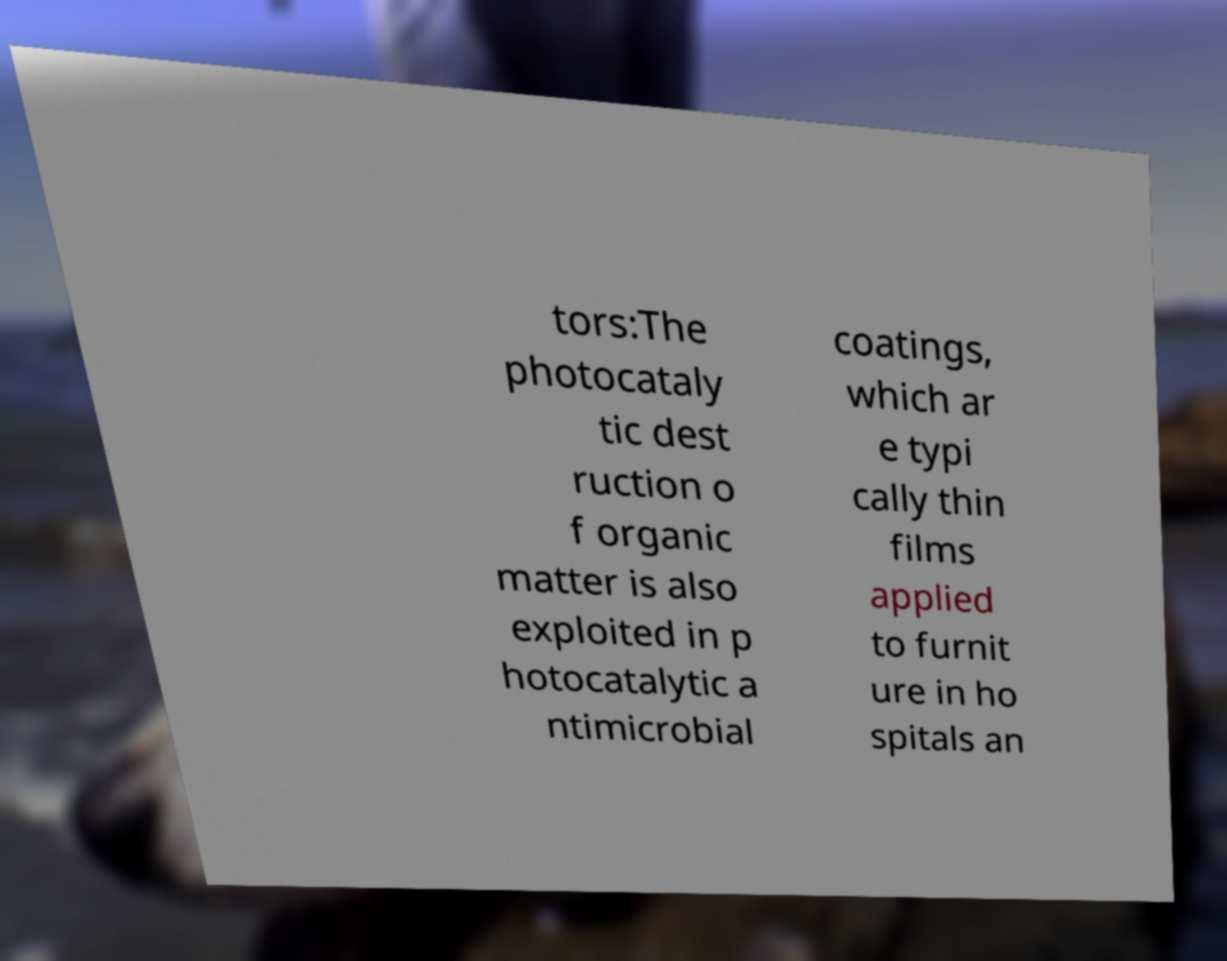What messages or text are displayed in this image? I need them in a readable, typed format. tors:The photocataly tic dest ruction o f organic matter is also exploited in p hotocatalytic a ntimicrobial coatings, which ar e typi cally thin films applied to furnit ure in ho spitals an 